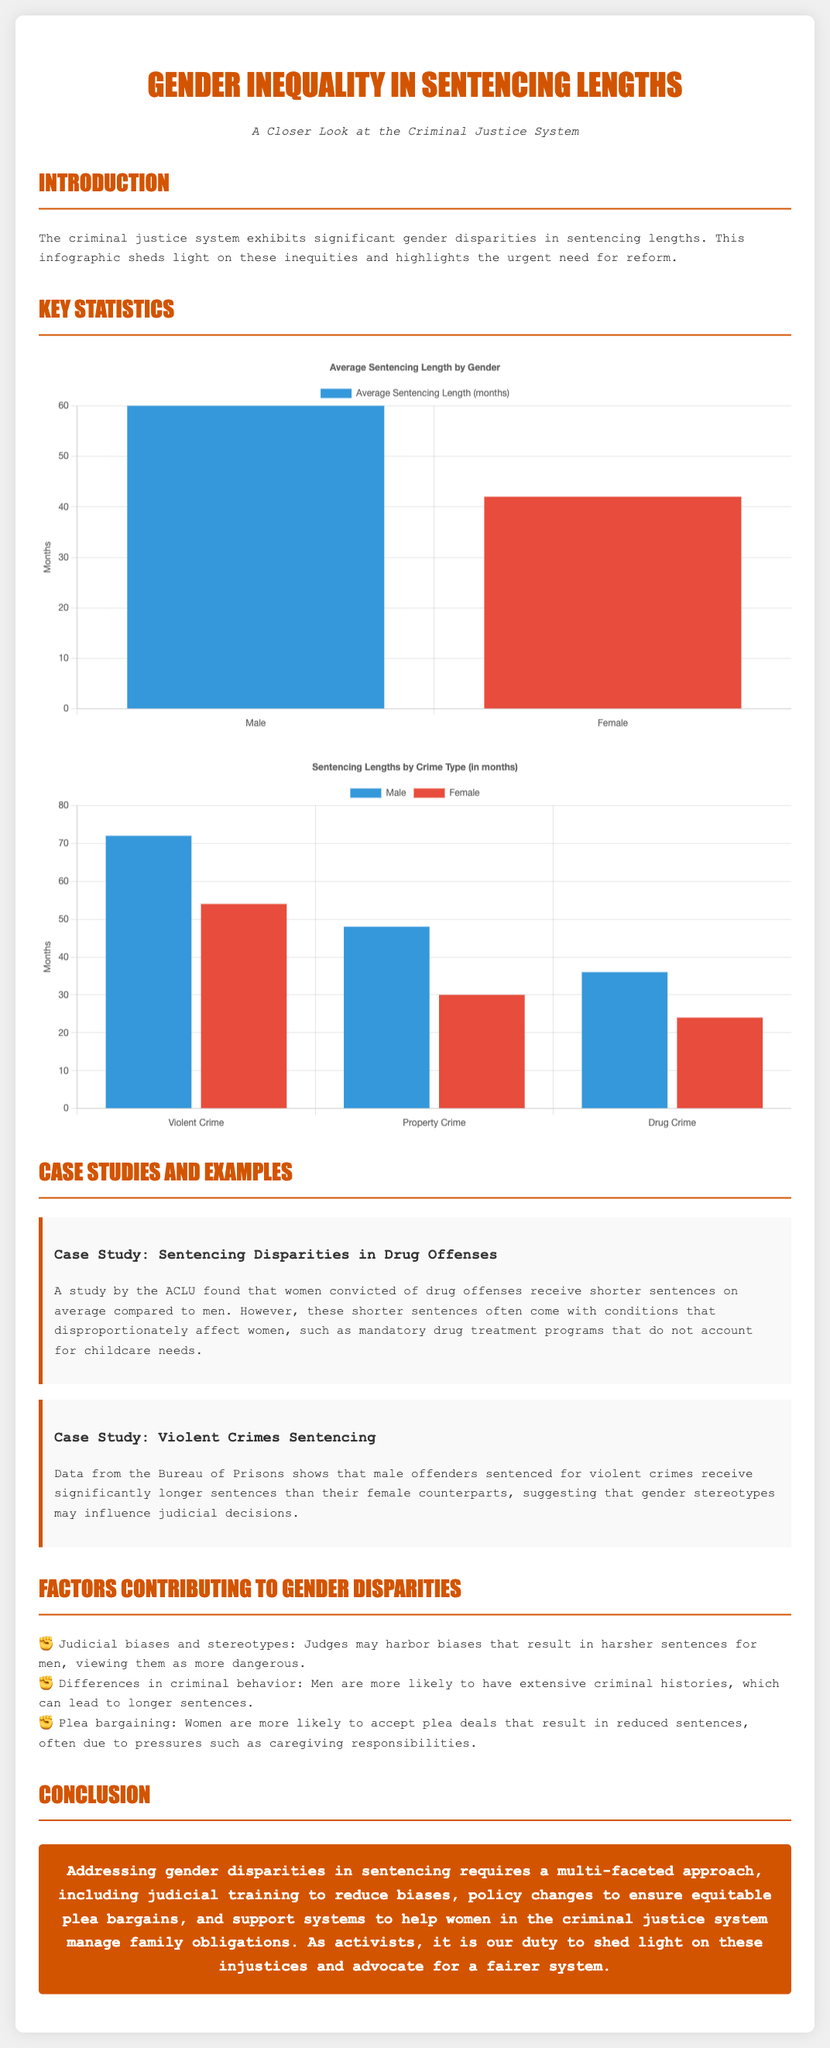What is the average sentencing length for males? The average sentencing length for males is 60 months, as indicated in the average sentencing length chart.
Answer: 60 months What is the average sentencing length for females? The average sentencing length for females is 42 months, based on the data presented in the document.
Answer: 42 months How many months are men sentenced for violent crimes on average? The average length of sentencing for men for violent crimes is 72 months, as indicated in the crime type sentencing chart.
Answer: 72 months What is the average sentencing length for women for property crimes? Women are sentenced to an average of 30 months for property crimes, according to the sentencing data provided.
Answer: 30 months Which organization conducted the study on sentencing disparities in drug offenses? The document states that a study on the sentencing disparities in drug offenses was conducted by the ACLU.
Answer: ACLU What are two factors contributing to gender disparities in sentencing mentioned in the document? The document lists judicial biases and differences in criminal behavior as two contributing factors to gender disparities in sentencing.
Answer: Judicial biases, Differences in criminal behavior What is the conclusion about addressing gender disparities in sentencing? The conclusion emphasizes that addressing gender disparities requires a multi-faceted approach, as summarized in the last section of the infographic.
Answer: Multi-faceted approach Which crime type has the highest average sentencing length for females? The crime type with the highest average sentencing length for females is violent crime, as shown in the crime type sentencing chart.
Answer: Violent crime What color is used to represent males in the crime type sentencing chart? The color used to represent males in the crime type sentencing chart is blue.
Answer: Blue 